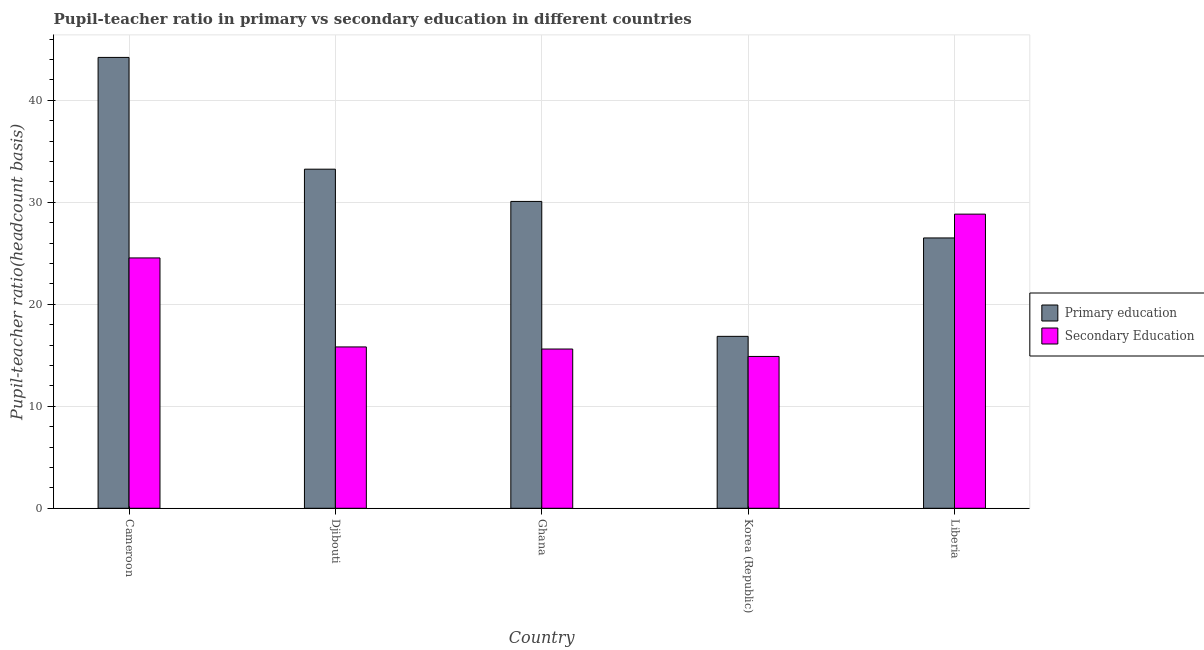How many groups of bars are there?
Provide a succinct answer. 5. Are the number of bars per tick equal to the number of legend labels?
Offer a terse response. Yes. Are the number of bars on each tick of the X-axis equal?
Your answer should be very brief. Yes. How many bars are there on the 4th tick from the right?
Ensure brevity in your answer.  2. What is the label of the 3rd group of bars from the left?
Provide a short and direct response. Ghana. In how many cases, is the number of bars for a given country not equal to the number of legend labels?
Give a very brief answer. 0. What is the pupil teacher ratio on secondary education in Liberia?
Provide a succinct answer. 28.83. Across all countries, what is the maximum pupil-teacher ratio in primary education?
Keep it short and to the point. 44.2. Across all countries, what is the minimum pupil teacher ratio on secondary education?
Ensure brevity in your answer.  14.88. In which country was the pupil-teacher ratio in primary education maximum?
Offer a very short reply. Cameroon. What is the total pupil-teacher ratio in primary education in the graph?
Ensure brevity in your answer.  150.87. What is the difference between the pupil teacher ratio on secondary education in Ghana and that in Liberia?
Provide a short and direct response. -13.22. What is the difference between the pupil-teacher ratio in primary education in Djibouti and the pupil teacher ratio on secondary education in Liberia?
Your answer should be compact. 4.41. What is the average pupil-teacher ratio in primary education per country?
Your answer should be very brief. 30.17. What is the difference between the pupil-teacher ratio in primary education and pupil teacher ratio on secondary education in Djibouti?
Provide a short and direct response. 17.42. In how many countries, is the pupil-teacher ratio in primary education greater than 28 ?
Your answer should be compact. 3. What is the ratio of the pupil-teacher ratio in primary education in Korea (Republic) to that in Liberia?
Give a very brief answer. 0.64. Is the pupil teacher ratio on secondary education in Djibouti less than that in Ghana?
Your answer should be very brief. No. What is the difference between the highest and the second highest pupil-teacher ratio in primary education?
Make the answer very short. 10.96. What is the difference between the highest and the lowest pupil teacher ratio on secondary education?
Offer a terse response. 13.95. Is the sum of the pupil teacher ratio on secondary education in Djibouti and Korea (Republic) greater than the maximum pupil-teacher ratio in primary education across all countries?
Give a very brief answer. No. What does the 2nd bar from the right in Korea (Republic) represents?
Offer a terse response. Primary education. Are all the bars in the graph horizontal?
Your response must be concise. No. Does the graph contain any zero values?
Offer a very short reply. No. What is the title of the graph?
Offer a very short reply. Pupil-teacher ratio in primary vs secondary education in different countries. What is the label or title of the Y-axis?
Provide a succinct answer. Pupil-teacher ratio(headcount basis). What is the Pupil-teacher ratio(headcount basis) of Primary education in Cameroon?
Keep it short and to the point. 44.2. What is the Pupil-teacher ratio(headcount basis) of Secondary Education in Cameroon?
Ensure brevity in your answer.  24.54. What is the Pupil-teacher ratio(headcount basis) in Primary education in Djibouti?
Make the answer very short. 33.24. What is the Pupil-teacher ratio(headcount basis) of Secondary Education in Djibouti?
Make the answer very short. 15.82. What is the Pupil-teacher ratio(headcount basis) of Primary education in Ghana?
Make the answer very short. 30.08. What is the Pupil-teacher ratio(headcount basis) of Secondary Education in Ghana?
Make the answer very short. 15.61. What is the Pupil-teacher ratio(headcount basis) in Primary education in Korea (Republic)?
Ensure brevity in your answer.  16.85. What is the Pupil-teacher ratio(headcount basis) of Secondary Education in Korea (Republic)?
Ensure brevity in your answer.  14.88. What is the Pupil-teacher ratio(headcount basis) in Primary education in Liberia?
Make the answer very short. 26.5. What is the Pupil-teacher ratio(headcount basis) in Secondary Education in Liberia?
Your answer should be very brief. 28.83. Across all countries, what is the maximum Pupil-teacher ratio(headcount basis) in Primary education?
Keep it short and to the point. 44.2. Across all countries, what is the maximum Pupil-teacher ratio(headcount basis) in Secondary Education?
Give a very brief answer. 28.83. Across all countries, what is the minimum Pupil-teacher ratio(headcount basis) of Primary education?
Your answer should be very brief. 16.85. Across all countries, what is the minimum Pupil-teacher ratio(headcount basis) of Secondary Education?
Provide a succinct answer. 14.88. What is the total Pupil-teacher ratio(headcount basis) of Primary education in the graph?
Offer a very short reply. 150.87. What is the total Pupil-teacher ratio(headcount basis) in Secondary Education in the graph?
Keep it short and to the point. 99.68. What is the difference between the Pupil-teacher ratio(headcount basis) in Primary education in Cameroon and that in Djibouti?
Offer a very short reply. 10.96. What is the difference between the Pupil-teacher ratio(headcount basis) in Secondary Education in Cameroon and that in Djibouti?
Your answer should be compact. 8.72. What is the difference between the Pupil-teacher ratio(headcount basis) of Primary education in Cameroon and that in Ghana?
Keep it short and to the point. 14.12. What is the difference between the Pupil-teacher ratio(headcount basis) of Secondary Education in Cameroon and that in Ghana?
Offer a terse response. 8.93. What is the difference between the Pupil-teacher ratio(headcount basis) in Primary education in Cameroon and that in Korea (Republic)?
Provide a succinct answer. 27.34. What is the difference between the Pupil-teacher ratio(headcount basis) in Secondary Education in Cameroon and that in Korea (Republic)?
Keep it short and to the point. 9.66. What is the difference between the Pupil-teacher ratio(headcount basis) in Primary education in Cameroon and that in Liberia?
Ensure brevity in your answer.  17.7. What is the difference between the Pupil-teacher ratio(headcount basis) of Secondary Education in Cameroon and that in Liberia?
Give a very brief answer. -4.29. What is the difference between the Pupil-teacher ratio(headcount basis) of Primary education in Djibouti and that in Ghana?
Offer a terse response. 3.16. What is the difference between the Pupil-teacher ratio(headcount basis) in Secondary Education in Djibouti and that in Ghana?
Your response must be concise. 0.2. What is the difference between the Pupil-teacher ratio(headcount basis) of Primary education in Djibouti and that in Korea (Republic)?
Provide a short and direct response. 16.39. What is the difference between the Pupil-teacher ratio(headcount basis) in Secondary Education in Djibouti and that in Korea (Republic)?
Your response must be concise. 0.93. What is the difference between the Pupil-teacher ratio(headcount basis) in Primary education in Djibouti and that in Liberia?
Make the answer very short. 6.74. What is the difference between the Pupil-teacher ratio(headcount basis) in Secondary Education in Djibouti and that in Liberia?
Offer a terse response. -13.02. What is the difference between the Pupil-teacher ratio(headcount basis) of Primary education in Ghana and that in Korea (Republic)?
Offer a very short reply. 13.23. What is the difference between the Pupil-teacher ratio(headcount basis) of Secondary Education in Ghana and that in Korea (Republic)?
Offer a terse response. 0.73. What is the difference between the Pupil-teacher ratio(headcount basis) of Primary education in Ghana and that in Liberia?
Provide a succinct answer. 3.58. What is the difference between the Pupil-teacher ratio(headcount basis) in Secondary Education in Ghana and that in Liberia?
Ensure brevity in your answer.  -13.22. What is the difference between the Pupil-teacher ratio(headcount basis) in Primary education in Korea (Republic) and that in Liberia?
Your answer should be very brief. -9.65. What is the difference between the Pupil-teacher ratio(headcount basis) of Secondary Education in Korea (Republic) and that in Liberia?
Your answer should be compact. -13.95. What is the difference between the Pupil-teacher ratio(headcount basis) of Primary education in Cameroon and the Pupil-teacher ratio(headcount basis) of Secondary Education in Djibouti?
Offer a very short reply. 28.38. What is the difference between the Pupil-teacher ratio(headcount basis) in Primary education in Cameroon and the Pupil-teacher ratio(headcount basis) in Secondary Education in Ghana?
Your response must be concise. 28.58. What is the difference between the Pupil-teacher ratio(headcount basis) of Primary education in Cameroon and the Pupil-teacher ratio(headcount basis) of Secondary Education in Korea (Republic)?
Your answer should be compact. 29.31. What is the difference between the Pupil-teacher ratio(headcount basis) in Primary education in Cameroon and the Pupil-teacher ratio(headcount basis) in Secondary Education in Liberia?
Keep it short and to the point. 15.36. What is the difference between the Pupil-teacher ratio(headcount basis) in Primary education in Djibouti and the Pupil-teacher ratio(headcount basis) in Secondary Education in Ghana?
Your answer should be very brief. 17.63. What is the difference between the Pupil-teacher ratio(headcount basis) in Primary education in Djibouti and the Pupil-teacher ratio(headcount basis) in Secondary Education in Korea (Republic)?
Make the answer very short. 18.36. What is the difference between the Pupil-teacher ratio(headcount basis) in Primary education in Djibouti and the Pupil-teacher ratio(headcount basis) in Secondary Education in Liberia?
Your answer should be compact. 4.41. What is the difference between the Pupil-teacher ratio(headcount basis) in Primary education in Ghana and the Pupil-teacher ratio(headcount basis) in Secondary Education in Korea (Republic)?
Offer a terse response. 15.2. What is the difference between the Pupil-teacher ratio(headcount basis) of Primary education in Ghana and the Pupil-teacher ratio(headcount basis) of Secondary Education in Liberia?
Your response must be concise. 1.25. What is the difference between the Pupil-teacher ratio(headcount basis) in Primary education in Korea (Republic) and the Pupil-teacher ratio(headcount basis) in Secondary Education in Liberia?
Ensure brevity in your answer.  -11.98. What is the average Pupil-teacher ratio(headcount basis) of Primary education per country?
Your response must be concise. 30.17. What is the average Pupil-teacher ratio(headcount basis) of Secondary Education per country?
Provide a short and direct response. 19.94. What is the difference between the Pupil-teacher ratio(headcount basis) in Primary education and Pupil-teacher ratio(headcount basis) in Secondary Education in Cameroon?
Your response must be concise. 19.66. What is the difference between the Pupil-teacher ratio(headcount basis) in Primary education and Pupil-teacher ratio(headcount basis) in Secondary Education in Djibouti?
Make the answer very short. 17.42. What is the difference between the Pupil-teacher ratio(headcount basis) of Primary education and Pupil-teacher ratio(headcount basis) of Secondary Education in Ghana?
Your response must be concise. 14.47. What is the difference between the Pupil-teacher ratio(headcount basis) in Primary education and Pupil-teacher ratio(headcount basis) in Secondary Education in Korea (Republic)?
Give a very brief answer. 1.97. What is the difference between the Pupil-teacher ratio(headcount basis) of Primary education and Pupil-teacher ratio(headcount basis) of Secondary Education in Liberia?
Ensure brevity in your answer.  -2.33. What is the ratio of the Pupil-teacher ratio(headcount basis) of Primary education in Cameroon to that in Djibouti?
Provide a short and direct response. 1.33. What is the ratio of the Pupil-teacher ratio(headcount basis) of Secondary Education in Cameroon to that in Djibouti?
Offer a terse response. 1.55. What is the ratio of the Pupil-teacher ratio(headcount basis) of Primary education in Cameroon to that in Ghana?
Keep it short and to the point. 1.47. What is the ratio of the Pupil-teacher ratio(headcount basis) of Secondary Education in Cameroon to that in Ghana?
Keep it short and to the point. 1.57. What is the ratio of the Pupil-teacher ratio(headcount basis) in Primary education in Cameroon to that in Korea (Republic)?
Provide a succinct answer. 2.62. What is the ratio of the Pupil-teacher ratio(headcount basis) of Secondary Education in Cameroon to that in Korea (Republic)?
Provide a succinct answer. 1.65. What is the ratio of the Pupil-teacher ratio(headcount basis) in Primary education in Cameroon to that in Liberia?
Give a very brief answer. 1.67. What is the ratio of the Pupil-teacher ratio(headcount basis) of Secondary Education in Cameroon to that in Liberia?
Your answer should be very brief. 0.85. What is the ratio of the Pupil-teacher ratio(headcount basis) in Primary education in Djibouti to that in Ghana?
Ensure brevity in your answer.  1.11. What is the ratio of the Pupil-teacher ratio(headcount basis) in Secondary Education in Djibouti to that in Ghana?
Give a very brief answer. 1.01. What is the ratio of the Pupil-teacher ratio(headcount basis) of Primary education in Djibouti to that in Korea (Republic)?
Give a very brief answer. 1.97. What is the ratio of the Pupil-teacher ratio(headcount basis) of Secondary Education in Djibouti to that in Korea (Republic)?
Ensure brevity in your answer.  1.06. What is the ratio of the Pupil-teacher ratio(headcount basis) of Primary education in Djibouti to that in Liberia?
Give a very brief answer. 1.25. What is the ratio of the Pupil-teacher ratio(headcount basis) in Secondary Education in Djibouti to that in Liberia?
Your answer should be very brief. 0.55. What is the ratio of the Pupil-teacher ratio(headcount basis) of Primary education in Ghana to that in Korea (Republic)?
Provide a succinct answer. 1.78. What is the ratio of the Pupil-teacher ratio(headcount basis) in Secondary Education in Ghana to that in Korea (Republic)?
Ensure brevity in your answer.  1.05. What is the ratio of the Pupil-teacher ratio(headcount basis) in Primary education in Ghana to that in Liberia?
Make the answer very short. 1.14. What is the ratio of the Pupil-teacher ratio(headcount basis) of Secondary Education in Ghana to that in Liberia?
Keep it short and to the point. 0.54. What is the ratio of the Pupil-teacher ratio(headcount basis) in Primary education in Korea (Republic) to that in Liberia?
Your answer should be very brief. 0.64. What is the ratio of the Pupil-teacher ratio(headcount basis) of Secondary Education in Korea (Republic) to that in Liberia?
Offer a very short reply. 0.52. What is the difference between the highest and the second highest Pupil-teacher ratio(headcount basis) of Primary education?
Give a very brief answer. 10.96. What is the difference between the highest and the second highest Pupil-teacher ratio(headcount basis) in Secondary Education?
Give a very brief answer. 4.29. What is the difference between the highest and the lowest Pupil-teacher ratio(headcount basis) of Primary education?
Give a very brief answer. 27.34. What is the difference between the highest and the lowest Pupil-teacher ratio(headcount basis) in Secondary Education?
Offer a terse response. 13.95. 